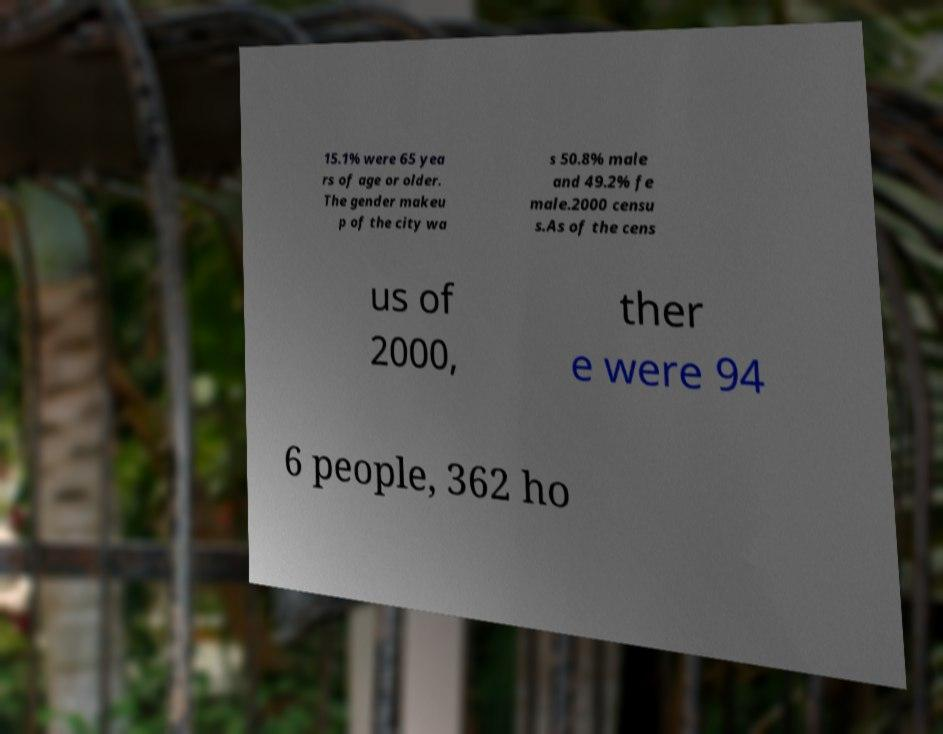There's text embedded in this image that I need extracted. Can you transcribe it verbatim? 15.1% were 65 yea rs of age or older. The gender makeu p of the city wa s 50.8% male and 49.2% fe male.2000 censu s.As of the cens us of 2000, ther e were 94 6 people, 362 ho 